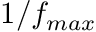<formula> <loc_0><loc_0><loc_500><loc_500>1 / f _ { \max }</formula> 